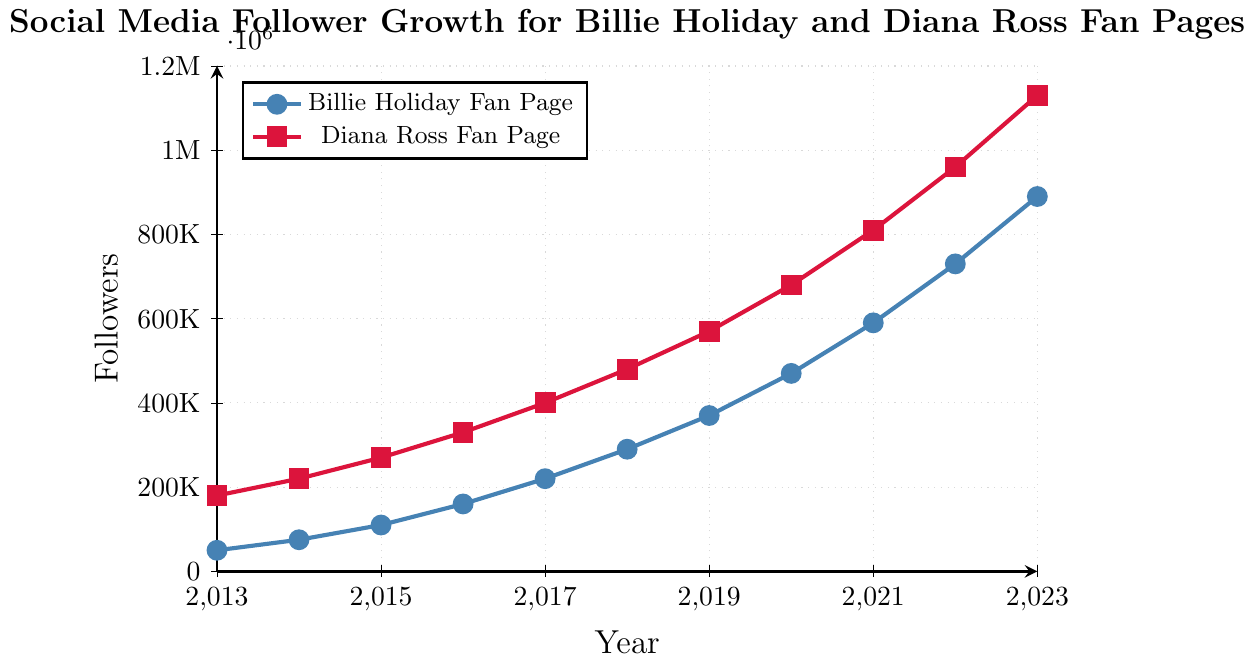What is the follower difference between the Billie Holiday and Diana Ross fan pages in 2013? To find the follower difference between the Billie Holiday and Diana Ross fan pages in 2013, subtract the number of Billie Holiday followers from the number of Diana Ross followers: 180,000 - 50,000 = 130,000
Answer: 130,000 Which artist's fan page had greater follower growth from 2019 to 2020? To determine which artist's fan page had greater follower growth from 2019 to 2020, subtract the 2019 follower count from the 2020 follower count for both artists. For Billie Holiday: 470,000 - 370,000 = 100,000. For Diana Ross: 680,000 - 570,000 = 110,000. Compare the growth: 100,000 (Billie Holiday) vs. 110,000 (Diana Ross).
Answer: Diana Ross Between which consecutive years did the Billie Holiday fan page see the highest increase in followers? Calculate the annual increase in followers for each consecutive year for the Billie Holiday fan page and find the maximum value: 
2014-2013: 75,000 - 50,000 = 25,000,
2015-2014: 110,000 - 75,000 = 35,000,
2016-2015: 160,000 - 110,000 = 50,000,
2017-2016: 220,000 - 160,000 = 60,000,
2018-2017: 290,000 - 220,000 = 70,000,
2019-2018: 370,000 - 290,000 = 80,000,
2020-2019: 470,000 - 370,000 = 100,000,
2021-2020: 590,000 - 470,000 = 120,000,
2022-2021: 730,000 - 590,000 = 140,000,
2023-2022: 890,000 - 730,000 = 160,000. 
The highest increase is 160,000 from 2022 to 2023.
Answer: 2022 to 2023 Does the Diana Ross fan page always have more followers than the Billie Holiday fan page? Compare the follower counts for Diana Ross and Billie Holiday fan pages for every year between 2013 and 2023. In every year, the Diana Ross fan page follower count is higher than the Billie Holiday fan page follower count.
Answer: Yes In which year did both fan pages achieve at least 200,000 followers? Find the first year where both fan pages had at least 200,000 followers. Billie Holiday fan page reached 200,000 followers in 2017 (220,000). Diana Ross fan page had already surpassed 200,000 in earlier years.
Answer: 2017 What is the average yearly growth in followers for the Billie Holiday fan page from 2013 to 2023? Calculate the yearly growth for each year by subtracting the follower count of the previous year from the follower count of the current year, sum up all the yearly growth values, and divide by the number of years (10):
(75,000 - 50,000) + (110,000 - 75,000) + (160,000 - 110,000) + (220,000 - 160,000) + (290,000 - 220,000) + (370,000 - 290,000) + (470,000 - 370,000) + (590,000 - 470,000) + (730,000 - 590,000) + (890,000 - 730,000) = 840,000. Divide by 10: 840,000 / 10 = 84,000
Answer: 84,000 By what percentage did the followers for the Diana Ross fan page increase from 2013 to 2023? Calculate the percentage increase by subtracting the initial value from the final value, divide by the initial value, and multiply by 100: (1,130,000 - 180,000) / 180,000 * 100 = 527.78%
Answer: 527.78% 